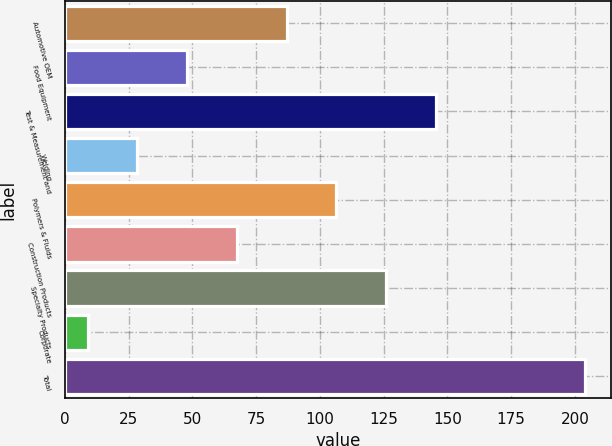Convert chart. <chart><loc_0><loc_0><loc_500><loc_500><bar_chart><fcel>Automotive OEM<fcel>Food Equipment<fcel>Test & Measurement and<fcel>Welding<fcel>Polymers & Fluids<fcel>Construction Products<fcel>Specialty Products<fcel>Corporate<fcel>Total<nl><fcel>87<fcel>48<fcel>145.5<fcel>28.5<fcel>106.5<fcel>67.5<fcel>126<fcel>9<fcel>204<nl></chart> 